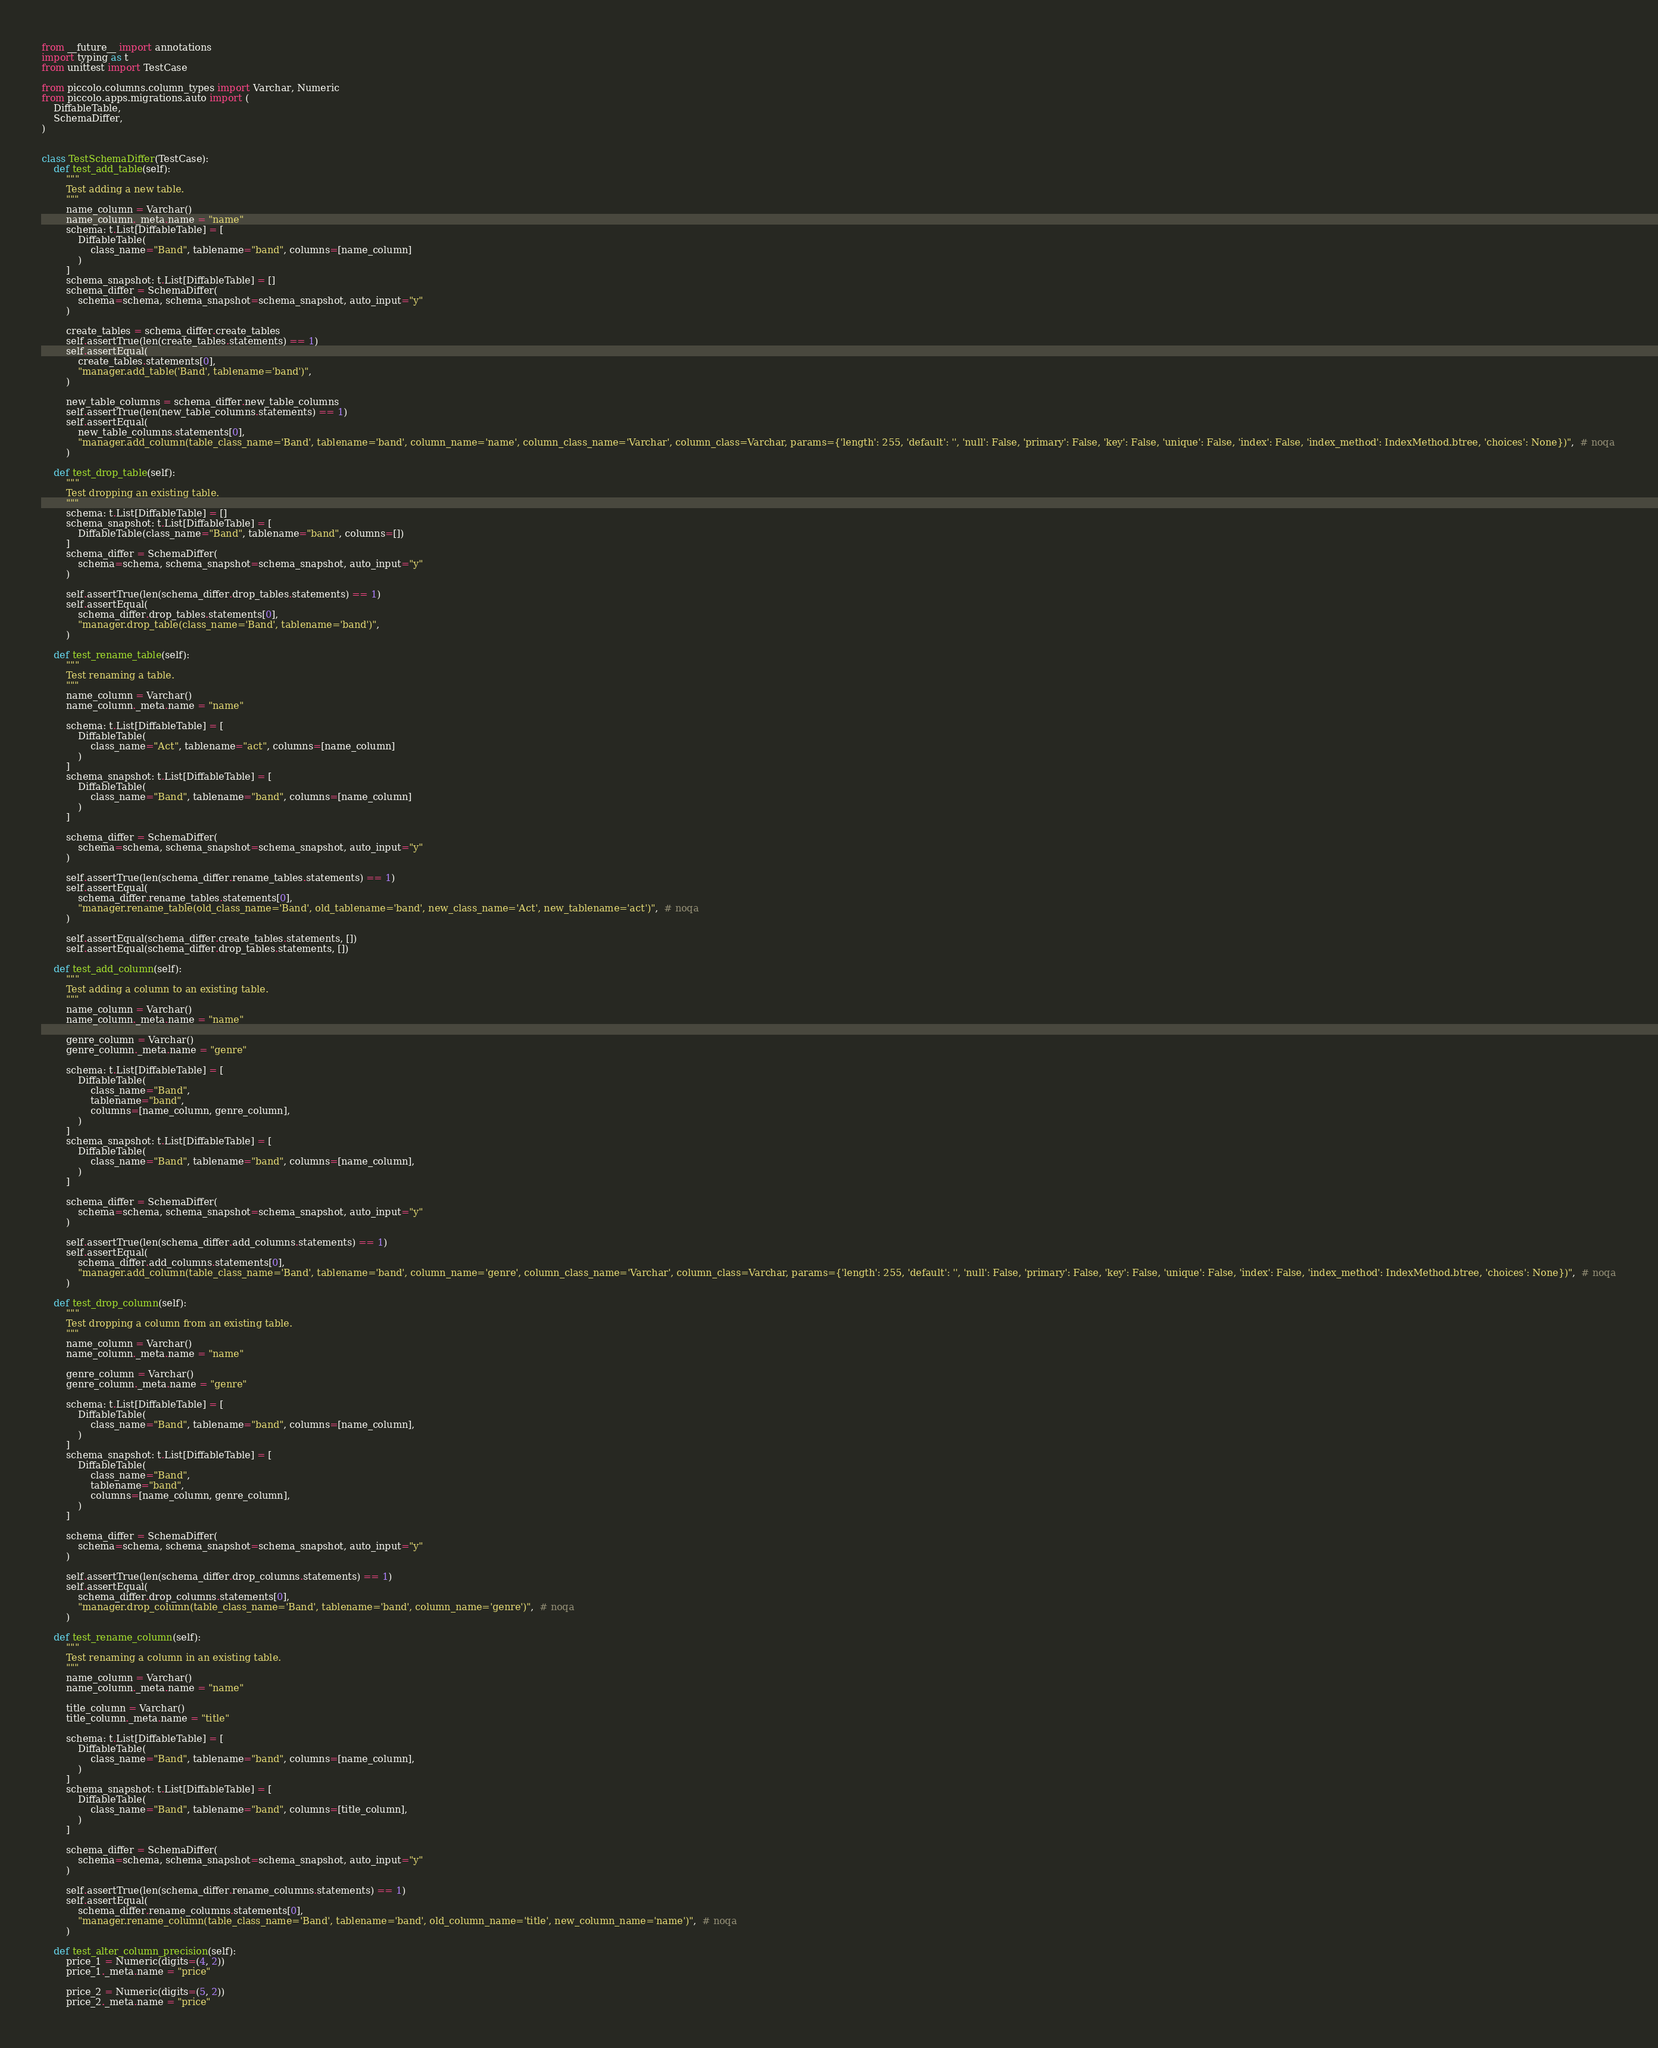<code> <loc_0><loc_0><loc_500><loc_500><_Python_>from __future__ import annotations
import typing as t
from unittest import TestCase

from piccolo.columns.column_types import Varchar, Numeric
from piccolo.apps.migrations.auto import (
    DiffableTable,
    SchemaDiffer,
)


class TestSchemaDiffer(TestCase):
    def test_add_table(self):
        """
        Test adding a new table.
        """
        name_column = Varchar()
        name_column._meta.name = "name"
        schema: t.List[DiffableTable] = [
            DiffableTable(
                class_name="Band", tablename="band", columns=[name_column]
            )
        ]
        schema_snapshot: t.List[DiffableTable] = []
        schema_differ = SchemaDiffer(
            schema=schema, schema_snapshot=schema_snapshot, auto_input="y"
        )

        create_tables = schema_differ.create_tables
        self.assertTrue(len(create_tables.statements) == 1)
        self.assertEqual(
            create_tables.statements[0],
            "manager.add_table('Band', tablename='band')",
        )

        new_table_columns = schema_differ.new_table_columns
        self.assertTrue(len(new_table_columns.statements) == 1)
        self.assertEqual(
            new_table_columns.statements[0],
            "manager.add_column(table_class_name='Band', tablename='band', column_name='name', column_class_name='Varchar', column_class=Varchar, params={'length': 255, 'default': '', 'null': False, 'primary': False, 'key': False, 'unique': False, 'index': False, 'index_method': IndexMethod.btree, 'choices': None})",  # noqa
        )

    def test_drop_table(self):
        """
        Test dropping an existing table.
        """
        schema: t.List[DiffableTable] = []
        schema_snapshot: t.List[DiffableTable] = [
            DiffableTable(class_name="Band", tablename="band", columns=[])
        ]
        schema_differ = SchemaDiffer(
            schema=schema, schema_snapshot=schema_snapshot, auto_input="y"
        )

        self.assertTrue(len(schema_differ.drop_tables.statements) == 1)
        self.assertEqual(
            schema_differ.drop_tables.statements[0],
            "manager.drop_table(class_name='Band', tablename='band')",
        )

    def test_rename_table(self):
        """
        Test renaming a table.
        """
        name_column = Varchar()
        name_column._meta.name = "name"

        schema: t.List[DiffableTable] = [
            DiffableTable(
                class_name="Act", tablename="act", columns=[name_column]
            )
        ]
        schema_snapshot: t.List[DiffableTable] = [
            DiffableTable(
                class_name="Band", tablename="band", columns=[name_column]
            )
        ]

        schema_differ = SchemaDiffer(
            schema=schema, schema_snapshot=schema_snapshot, auto_input="y"
        )

        self.assertTrue(len(schema_differ.rename_tables.statements) == 1)
        self.assertEqual(
            schema_differ.rename_tables.statements[0],
            "manager.rename_table(old_class_name='Band', old_tablename='band', new_class_name='Act', new_tablename='act')",  # noqa
        )

        self.assertEqual(schema_differ.create_tables.statements, [])
        self.assertEqual(schema_differ.drop_tables.statements, [])

    def test_add_column(self):
        """
        Test adding a column to an existing table.
        """
        name_column = Varchar()
        name_column._meta.name = "name"

        genre_column = Varchar()
        genre_column._meta.name = "genre"

        schema: t.List[DiffableTable] = [
            DiffableTable(
                class_name="Band",
                tablename="band",
                columns=[name_column, genre_column],
            )
        ]
        schema_snapshot: t.List[DiffableTable] = [
            DiffableTable(
                class_name="Band", tablename="band", columns=[name_column],
            )
        ]

        schema_differ = SchemaDiffer(
            schema=schema, schema_snapshot=schema_snapshot, auto_input="y"
        )

        self.assertTrue(len(schema_differ.add_columns.statements) == 1)
        self.assertEqual(
            schema_differ.add_columns.statements[0],
            "manager.add_column(table_class_name='Band', tablename='band', column_name='genre', column_class_name='Varchar', column_class=Varchar, params={'length': 255, 'default': '', 'null': False, 'primary': False, 'key': False, 'unique': False, 'index': False, 'index_method': IndexMethod.btree, 'choices': None})",  # noqa
        )

    def test_drop_column(self):
        """
        Test dropping a column from an existing table.
        """
        name_column = Varchar()
        name_column._meta.name = "name"

        genre_column = Varchar()
        genre_column._meta.name = "genre"

        schema: t.List[DiffableTable] = [
            DiffableTable(
                class_name="Band", tablename="band", columns=[name_column],
            )
        ]
        schema_snapshot: t.List[DiffableTable] = [
            DiffableTable(
                class_name="Band",
                tablename="band",
                columns=[name_column, genre_column],
            )
        ]

        schema_differ = SchemaDiffer(
            schema=schema, schema_snapshot=schema_snapshot, auto_input="y"
        )

        self.assertTrue(len(schema_differ.drop_columns.statements) == 1)
        self.assertEqual(
            schema_differ.drop_columns.statements[0],
            "manager.drop_column(table_class_name='Band', tablename='band', column_name='genre')",  # noqa
        )

    def test_rename_column(self):
        """
        Test renaming a column in an existing table.
        """
        name_column = Varchar()
        name_column._meta.name = "name"

        title_column = Varchar()
        title_column._meta.name = "title"

        schema: t.List[DiffableTable] = [
            DiffableTable(
                class_name="Band", tablename="band", columns=[name_column],
            )
        ]
        schema_snapshot: t.List[DiffableTable] = [
            DiffableTable(
                class_name="Band", tablename="band", columns=[title_column],
            )
        ]

        schema_differ = SchemaDiffer(
            schema=schema, schema_snapshot=schema_snapshot, auto_input="y"
        )

        self.assertTrue(len(schema_differ.rename_columns.statements) == 1)
        self.assertEqual(
            schema_differ.rename_columns.statements[0],
            "manager.rename_column(table_class_name='Band', tablename='band', old_column_name='title', new_column_name='name')",  # noqa
        )

    def test_alter_column_precision(self):
        price_1 = Numeric(digits=(4, 2))
        price_1._meta.name = "price"

        price_2 = Numeric(digits=(5, 2))
        price_2._meta.name = "price"
</code> 